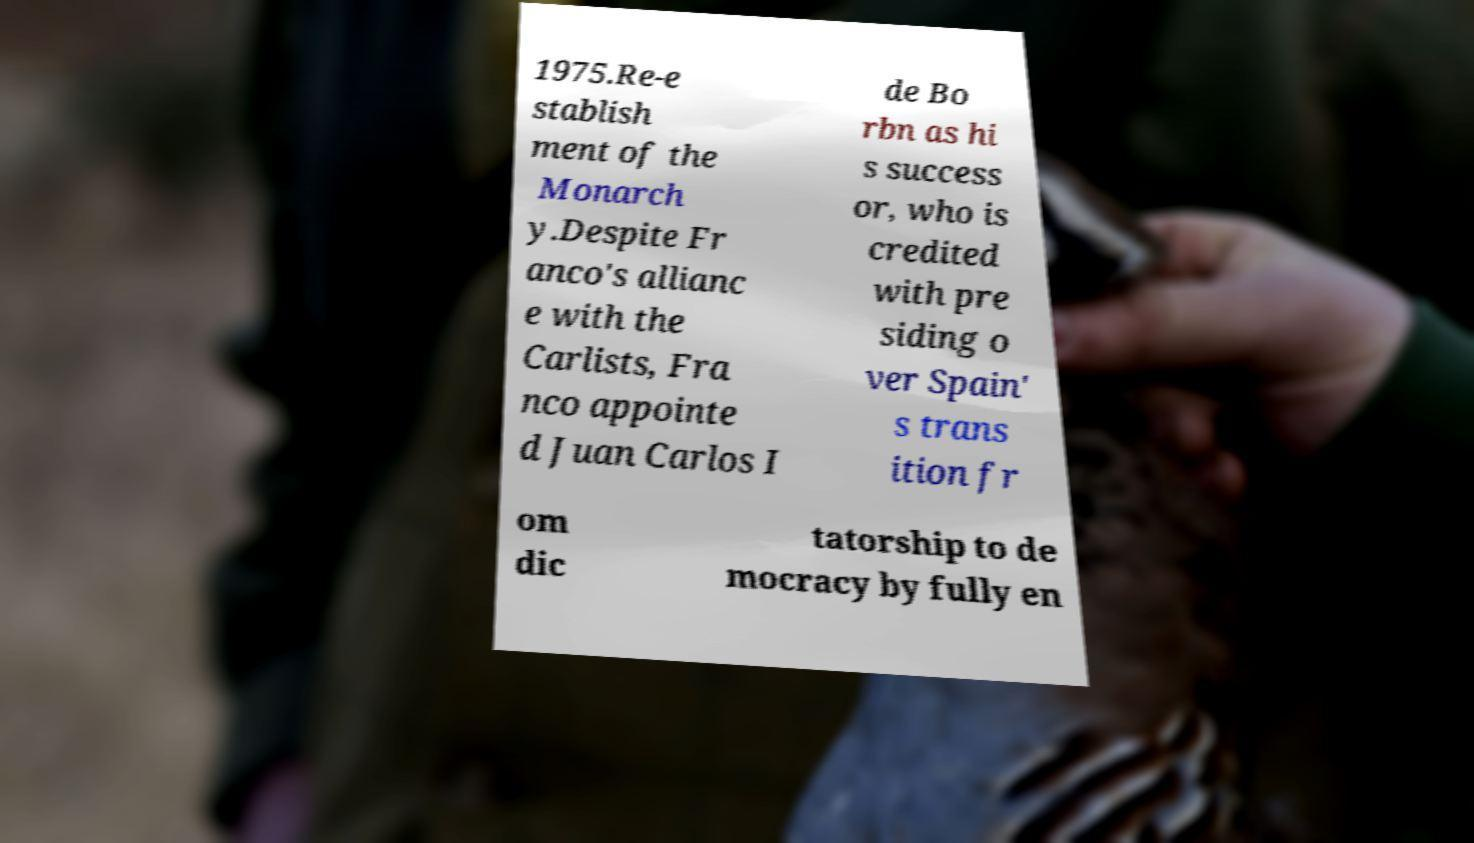Can you read and provide the text displayed in the image?This photo seems to have some interesting text. Can you extract and type it out for me? 1975.Re-e stablish ment of the Monarch y.Despite Fr anco's allianc e with the Carlists, Fra nco appointe d Juan Carlos I de Bo rbn as hi s success or, who is credited with pre siding o ver Spain' s trans ition fr om dic tatorship to de mocracy by fully en 